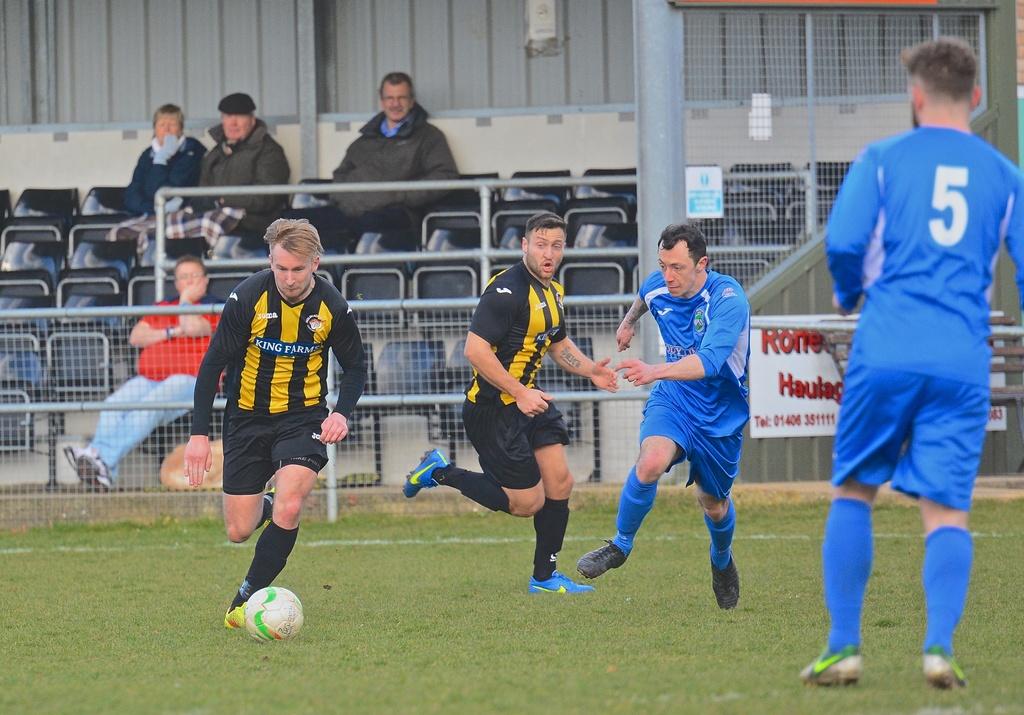What number is the player in the blue?
Give a very brief answer. 5. 